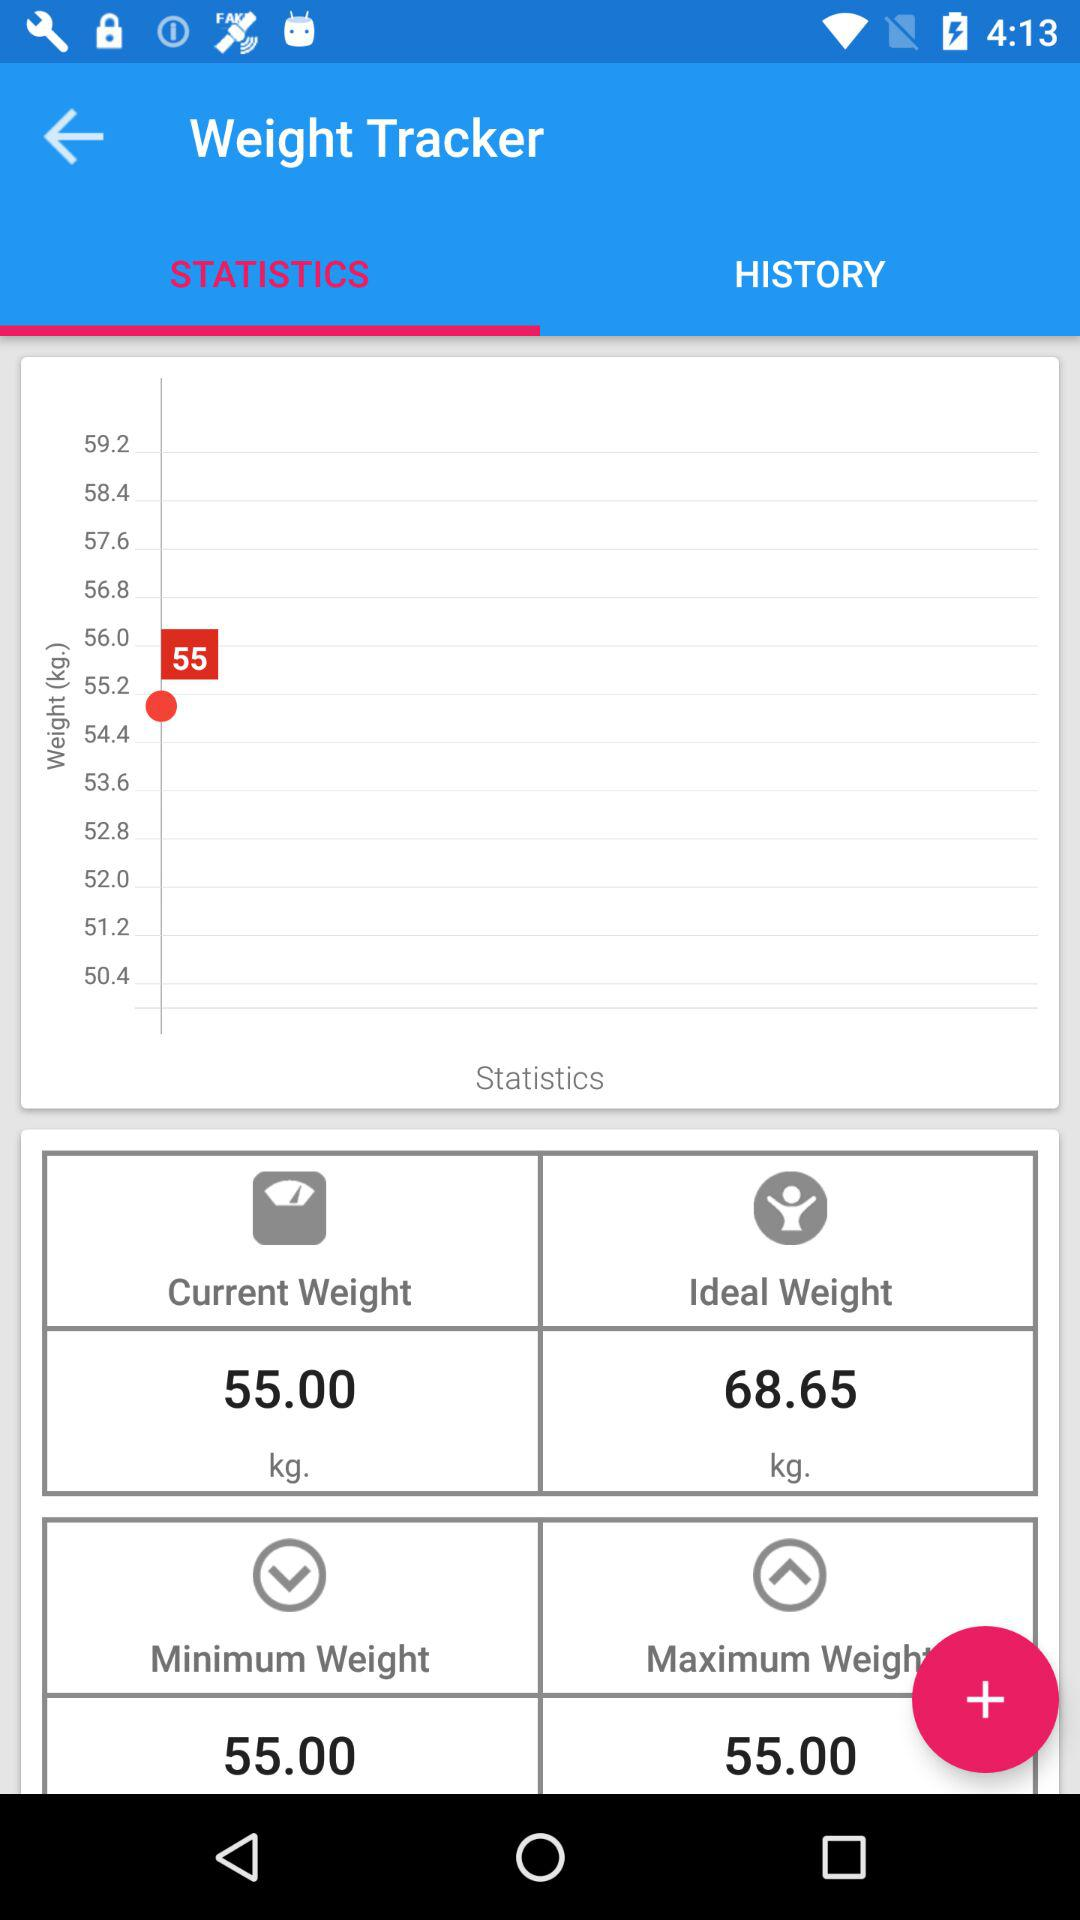What is the unit of weight? The unit of weight is the kilogram. 